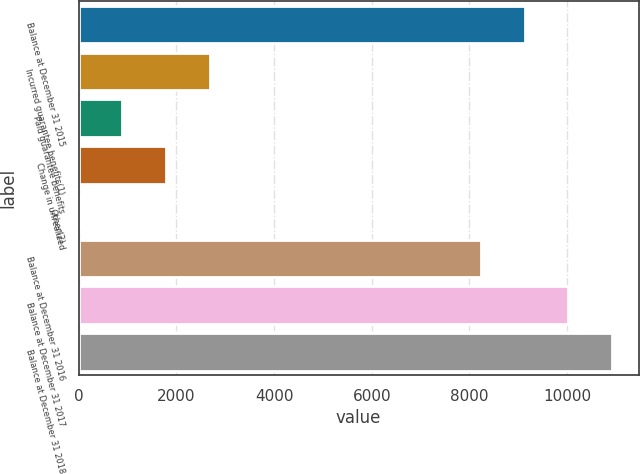Convert chart to OTSL. <chart><loc_0><loc_0><loc_500><loc_500><bar_chart><fcel>Balance at December 31 2015<fcel>Incurred guarantee benefits(1)<fcel>Paid guarantee benefits<fcel>Change in unrealized<fcel>Other(2)<fcel>Balance at December 31 2016<fcel>Balance at December 31 2017<fcel>Balance at December 31 2018<nl><fcel>9130.6<fcel>2678.8<fcel>893.6<fcel>1786.2<fcel>1<fcel>8238<fcel>10023.2<fcel>10915.8<nl></chart> 